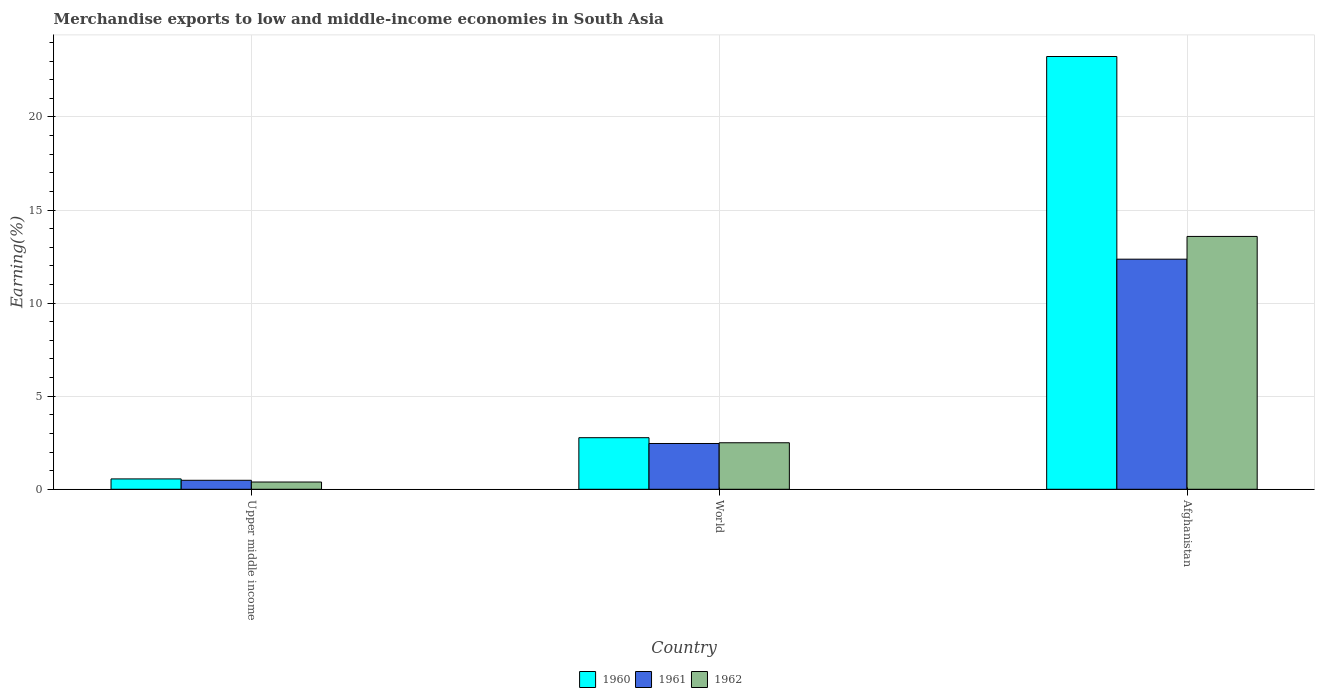How many different coloured bars are there?
Make the answer very short. 3. Are the number of bars on each tick of the X-axis equal?
Your response must be concise. Yes. In how many cases, is the number of bars for a given country not equal to the number of legend labels?
Keep it short and to the point. 0. What is the percentage of amount earned from merchandise exports in 1962 in World?
Make the answer very short. 2.5. Across all countries, what is the maximum percentage of amount earned from merchandise exports in 1961?
Give a very brief answer. 12.36. Across all countries, what is the minimum percentage of amount earned from merchandise exports in 1962?
Keep it short and to the point. 0.39. In which country was the percentage of amount earned from merchandise exports in 1961 maximum?
Provide a short and direct response. Afghanistan. In which country was the percentage of amount earned from merchandise exports in 1960 minimum?
Keep it short and to the point. Upper middle income. What is the total percentage of amount earned from merchandise exports in 1962 in the graph?
Provide a succinct answer. 16.47. What is the difference between the percentage of amount earned from merchandise exports in 1960 in Afghanistan and that in World?
Make the answer very short. 20.48. What is the difference between the percentage of amount earned from merchandise exports in 1960 in World and the percentage of amount earned from merchandise exports in 1962 in Afghanistan?
Give a very brief answer. -10.81. What is the average percentage of amount earned from merchandise exports in 1962 per country?
Keep it short and to the point. 5.49. What is the difference between the percentage of amount earned from merchandise exports of/in 1962 and percentage of amount earned from merchandise exports of/in 1960 in Afghanistan?
Make the answer very short. -9.66. What is the ratio of the percentage of amount earned from merchandise exports in 1961 in Afghanistan to that in World?
Offer a terse response. 5.03. Is the percentage of amount earned from merchandise exports in 1961 in Upper middle income less than that in World?
Offer a very short reply. Yes. What is the difference between the highest and the second highest percentage of amount earned from merchandise exports in 1961?
Offer a very short reply. -1.98. What is the difference between the highest and the lowest percentage of amount earned from merchandise exports in 1962?
Your answer should be compact. 13.19. What does the 1st bar from the right in Afghanistan represents?
Offer a very short reply. 1962. How many bars are there?
Give a very brief answer. 9. What is the difference between two consecutive major ticks on the Y-axis?
Offer a terse response. 5. Are the values on the major ticks of Y-axis written in scientific E-notation?
Keep it short and to the point. No. Does the graph contain any zero values?
Your response must be concise. No. Where does the legend appear in the graph?
Provide a succinct answer. Bottom center. What is the title of the graph?
Provide a short and direct response. Merchandise exports to low and middle-income economies in South Asia. What is the label or title of the X-axis?
Offer a terse response. Country. What is the label or title of the Y-axis?
Provide a short and direct response. Earning(%). What is the Earning(%) in 1960 in Upper middle income?
Keep it short and to the point. 0.56. What is the Earning(%) in 1961 in Upper middle income?
Provide a short and direct response. 0.48. What is the Earning(%) of 1962 in Upper middle income?
Your response must be concise. 0.39. What is the Earning(%) in 1960 in World?
Make the answer very short. 2.77. What is the Earning(%) in 1961 in World?
Offer a terse response. 2.46. What is the Earning(%) in 1962 in World?
Offer a very short reply. 2.5. What is the Earning(%) of 1960 in Afghanistan?
Keep it short and to the point. 23.25. What is the Earning(%) in 1961 in Afghanistan?
Your answer should be compact. 12.36. What is the Earning(%) in 1962 in Afghanistan?
Your answer should be compact. 13.58. Across all countries, what is the maximum Earning(%) of 1960?
Your response must be concise. 23.25. Across all countries, what is the maximum Earning(%) of 1961?
Give a very brief answer. 12.36. Across all countries, what is the maximum Earning(%) in 1962?
Your answer should be compact. 13.58. Across all countries, what is the minimum Earning(%) in 1960?
Provide a short and direct response. 0.56. Across all countries, what is the minimum Earning(%) in 1961?
Offer a very short reply. 0.48. Across all countries, what is the minimum Earning(%) of 1962?
Give a very brief answer. 0.39. What is the total Earning(%) of 1960 in the graph?
Give a very brief answer. 26.57. What is the total Earning(%) in 1961 in the graph?
Keep it short and to the point. 15.3. What is the total Earning(%) of 1962 in the graph?
Your response must be concise. 16.47. What is the difference between the Earning(%) of 1960 in Upper middle income and that in World?
Offer a very short reply. -2.21. What is the difference between the Earning(%) of 1961 in Upper middle income and that in World?
Offer a very short reply. -1.98. What is the difference between the Earning(%) in 1962 in Upper middle income and that in World?
Your answer should be compact. -2.11. What is the difference between the Earning(%) in 1960 in Upper middle income and that in Afghanistan?
Make the answer very short. -22.69. What is the difference between the Earning(%) in 1961 in Upper middle income and that in Afghanistan?
Keep it short and to the point. -11.88. What is the difference between the Earning(%) of 1962 in Upper middle income and that in Afghanistan?
Ensure brevity in your answer.  -13.19. What is the difference between the Earning(%) of 1960 in World and that in Afghanistan?
Your answer should be compact. -20.48. What is the difference between the Earning(%) of 1961 in World and that in Afghanistan?
Your answer should be compact. -9.9. What is the difference between the Earning(%) in 1962 in World and that in Afghanistan?
Ensure brevity in your answer.  -11.08. What is the difference between the Earning(%) in 1960 in Upper middle income and the Earning(%) in 1961 in World?
Make the answer very short. -1.9. What is the difference between the Earning(%) in 1960 in Upper middle income and the Earning(%) in 1962 in World?
Your answer should be very brief. -1.94. What is the difference between the Earning(%) in 1961 in Upper middle income and the Earning(%) in 1962 in World?
Keep it short and to the point. -2.02. What is the difference between the Earning(%) of 1960 in Upper middle income and the Earning(%) of 1961 in Afghanistan?
Your response must be concise. -11.8. What is the difference between the Earning(%) of 1960 in Upper middle income and the Earning(%) of 1962 in Afghanistan?
Your answer should be very brief. -13.03. What is the difference between the Earning(%) of 1961 in Upper middle income and the Earning(%) of 1962 in Afghanistan?
Your answer should be compact. -13.1. What is the difference between the Earning(%) of 1960 in World and the Earning(%) of 1961 in Afghanistan?
Make the answer very short. -9.59. What is the difference between the Earning(%) in 1960 in World and the Earning(%) in 1962 in Afghanistan?
Make the answer very short. -10.81. What is the difference between the Earning(%) in 1961 in World and the Earning(%) in 1962 in Afghanistan?
Ensure brevity in your answer.  -11.12. What is the average Earning(%) of 1960 per country?
Offer a terse response. 8.86. What is the average Earning(%) in 1961 per country?
Offer a terse response. 5.1. What is the average Earning(%) in 1962 per country?
Your answer should be compact. 5.49. What is the difference between the Earning(%) of 1960 and Earning(%) of 1961 in Upper middle income?
Offer a very short reply. 0.07. What is the difference between the Earning(%) in 1960 and Earning(%) in 1962 in Upper middle income?
Ensure brevity in your answer.  0.17. What is the difference between the Earning(%) in 1961 and Earning(%) in 1962 in Upper middle income?
Give a very brief answer. 0.09. What is the difference between the Earning(%) in 1960 and Earning(%) in 1961 in World?
Your response must be concise. 0.31. What is the difference between the Earning(%) in 1960 and Earning(%) in 1962 in World?
Make the answer very short. 0.27. What is the difference between the Earning(%) in 1961 and Earning(%) in 1962 in World?
Offer a very short reply. -0.04. What is the difference between the Earning(%) in 1960 and Earning(%) in 1961 in Afghanistan?
Provide a short and direct response. 10.89. What is the difference between the Earning(%) of 1960 and Earning(%) of 1962 in Afghanistan?
Make the answer very short. 9.66. What is the difference between the Earning(%) in 1961 and Earning(%) in 1962 in Afghanistan?
Ensure brevity in your answer.  -1.22. What is the ratio of the Earning(%) of 1960 in Upper middle income to that in World?
Provide a short and direct response. 0.2. What is the ratio of the Earning(%) of 1961 in Upper middle income to that in World?
Provide a succinct answer. 0.2. What is the ratio of the Earning(%) of 1962 in Upper middle income to that in World?
Your answer should be compact. 0.16. What is the ratio of the Earning(%) in 1960 in Upper middle income to that in Afghanistan?
Offer a very short reply. 0.02. What is the ratio of the Earning(%) in 1961 in Upper middle income to that in Afghanistan?
Give a very brief answer. 0.04. What is the ratio of the Earning(%) of 1962 in Upper middle income to that in Afghanistan?
Offer a terse response. 0.03. What is the ratio of the Earning(%) of 1960 in World to that in Afghanistan?
Offer a very short reply. 0.12. What is the ratio of the Earning(%) of 1961 in World to that in Afghanistan?
Keep it short and to the point. 0.2. What is the ratio of the Earning(%) of 1962 in World to that in Afghanistan?
Provide a short and direct response. 0.18. What is the difference between the highest and the second highest Earning(%) of 1960?
Provide a succinct answer. 20.48. What is the difference between the highest and the second highest Earning(%) of 1961?
Your response must be concise. 9.9. What is the difference between the highest and the second highest Earning(%) in 1962?
Provide a succinct answer. 11.08. What is the difference between the highest and the lowest Earning(%) of 1960?
Give a very brief answer. 22.69. What is the difference between the highest and the lowest Earning(%) of 1961?
Offer a very short reply. 11.88. What is the difference between the highest and the lowest Earning(%) in 1962?
Keep it short and to the point. 13.19. 